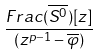Convert formula to latex. <formula><loc_0><loc_0><loc_500><loc_500>\frac { F r a c ( \overline { S ^ { 0 } } ) [ z ] } { ( z ^ { p - 1 } - \overline { \varphi } ) }</formula> 